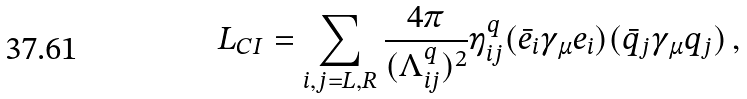Convert formula to latex. <formula><loc_0><loc_0><loc_500><loc_500>L _ { C I } = \sum _ { i , j = L , R } \frac { 4 \pi } { ( \Lambda _ { i j } ^ { q } ) ^ { 2 } } \eta _ { i j } ^ { q } ( \bar { e } _ { i } \gamma _ { \mu } e _ { i } ) ( \bar { q } _ { j } \gamma _ { \mu } q _ { j } ) \, ,</formula> 